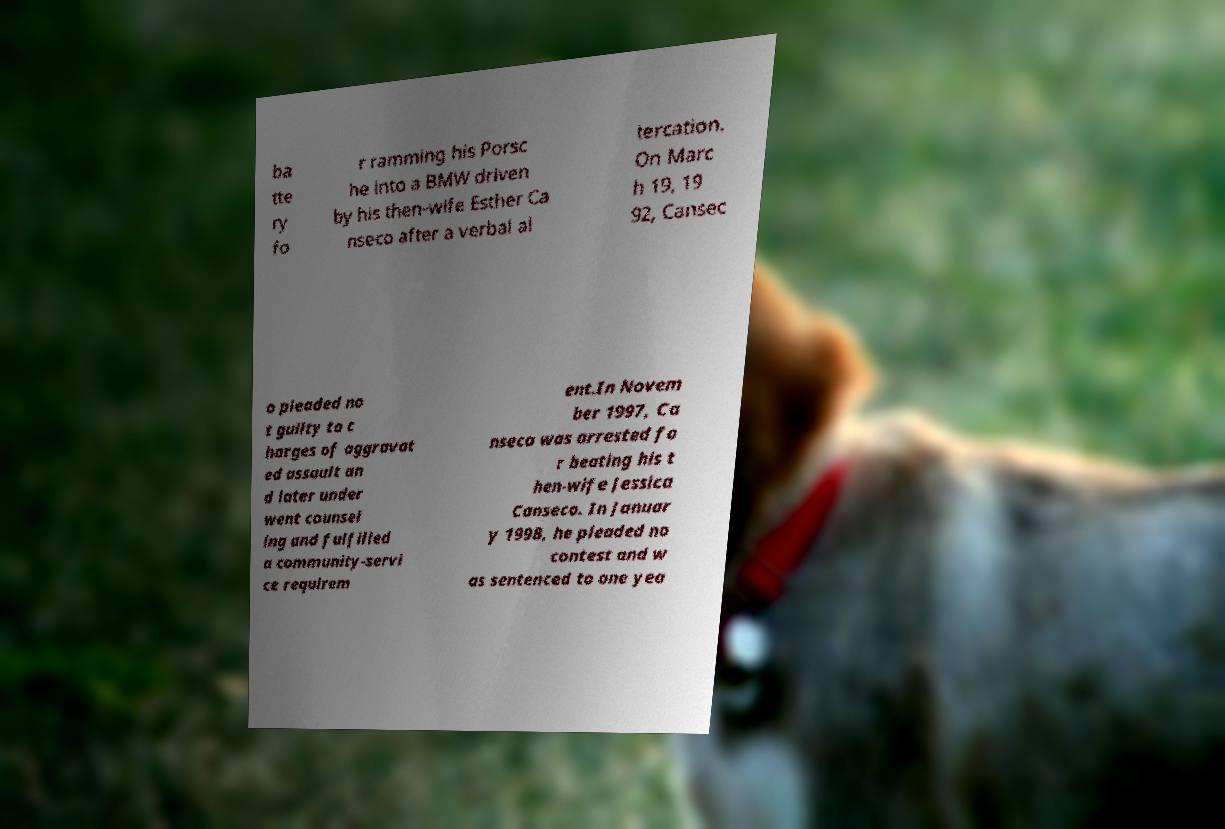I need the written content from this picture converted into text. Can you do that? ba tte ry fo r ramming his Porsc he into a BMW driven by his then-wife Esther Ca nseco after a verbal al tercation. On Marc h 19, 19 92, Cansec o pleaded no t guilty to c harges of aggravat ed assault an d later under went counsel ing and fulfilled a community-servi ce requirem ent.In Novem ber 1997, Ca nseco was arrested fo r beating his t hen-wife Jessica Canseco. In Januar y 1998, he pleaded no contest and w as sentenced to one yea 